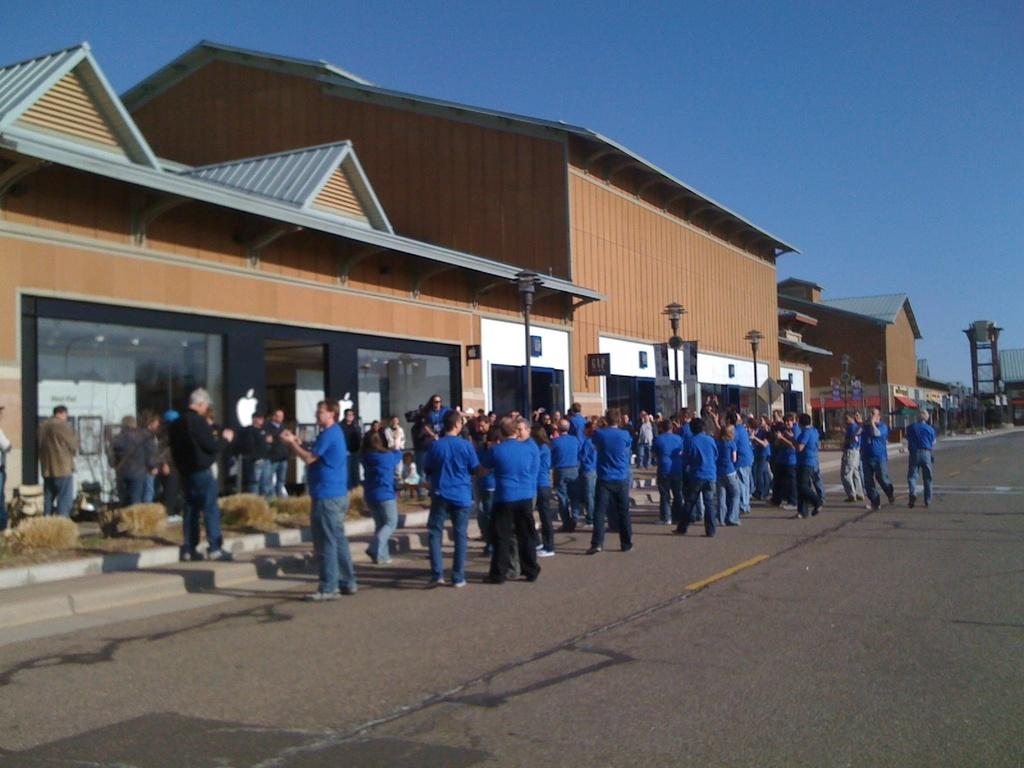What can be seen in the image? There are people standing in the image. What are the people wearing? Most of the people are wearing blue-colored dresses. What can be seen in the background of the image? There are buildings, streetlights, and the sky visible in the background of the image. What type of hammer can be seen in the hands of the people in the image? There is no hammer present in the image; the people are not holding any tools. 